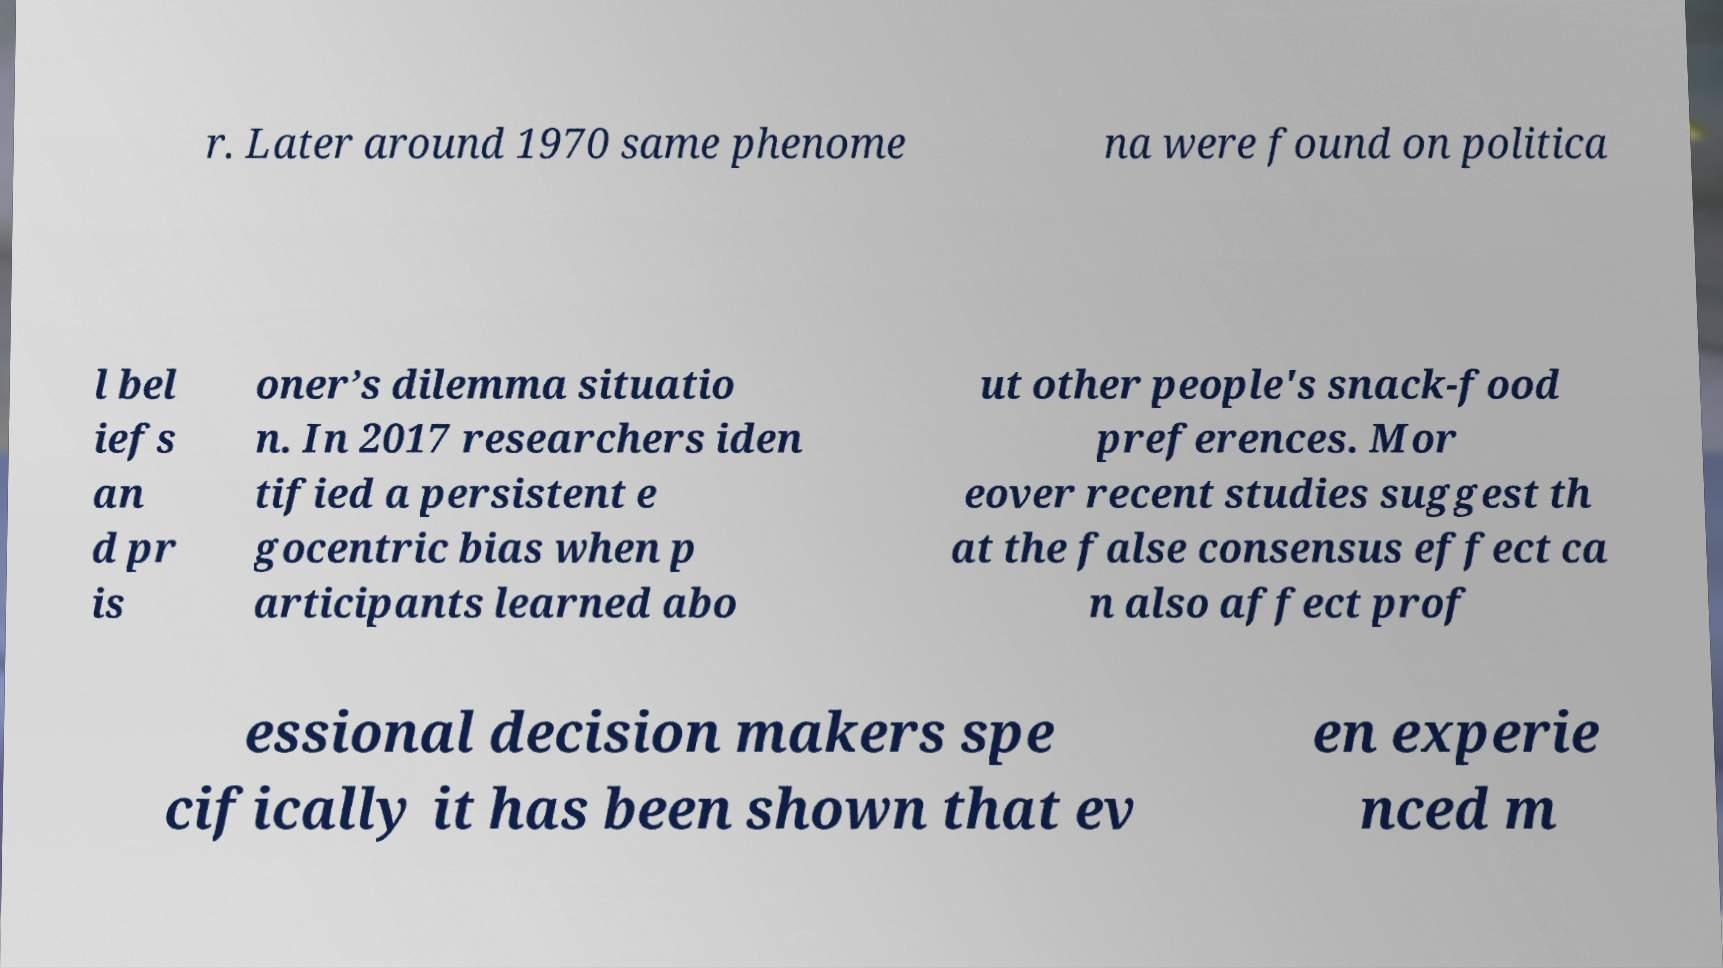For documentation purposes, I need the text within this image transcribed. Could you provide that? r. Later around 1970 same phenome na were found on politica l bel iefs an d pr is oner’s dilemma situatio n. In 2017 researchers iden tified a persistent e gocentric bias when p articipants learned abo ut other people's snack-food preferences. Mor eover recent studies suggest th at the false consensus effect ca n also affect prof essional decision makers spe cifically it has been shown that ev en experie nced m 